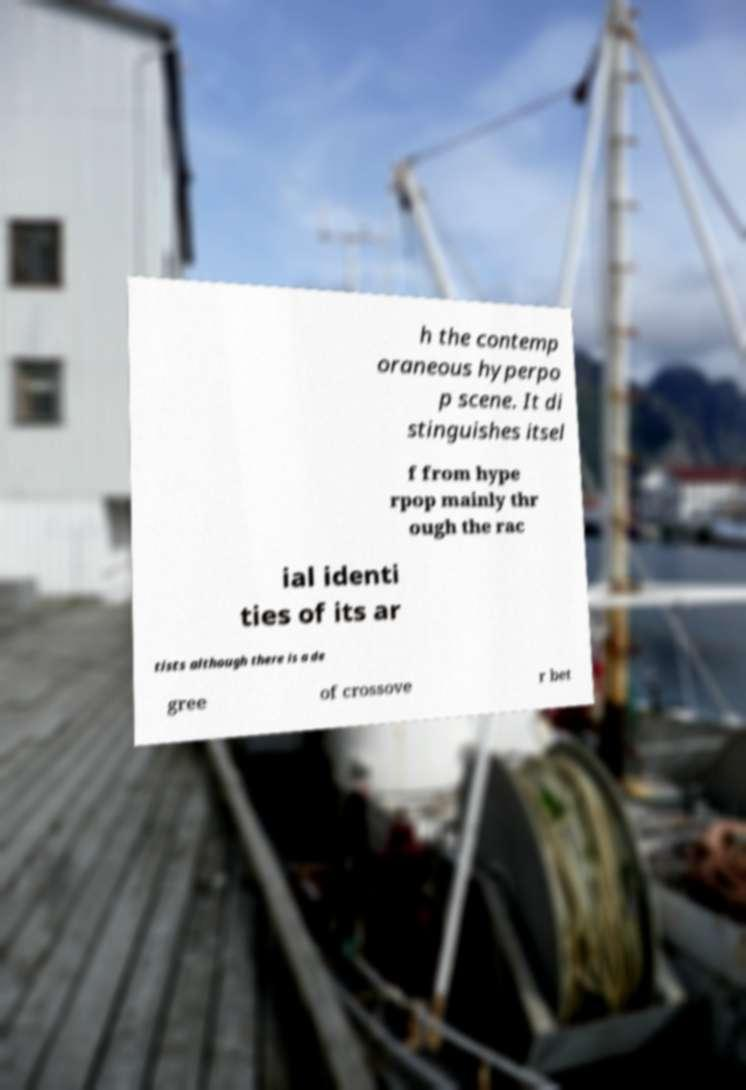Could you extract and type out the text from this image? h the contemp oraneous hyperpo p scene. It di stinguishes itsel f from hype rpop mainly thr ough the rac ial identi ties of its ar tists although there is a de gree of crossove r bet 